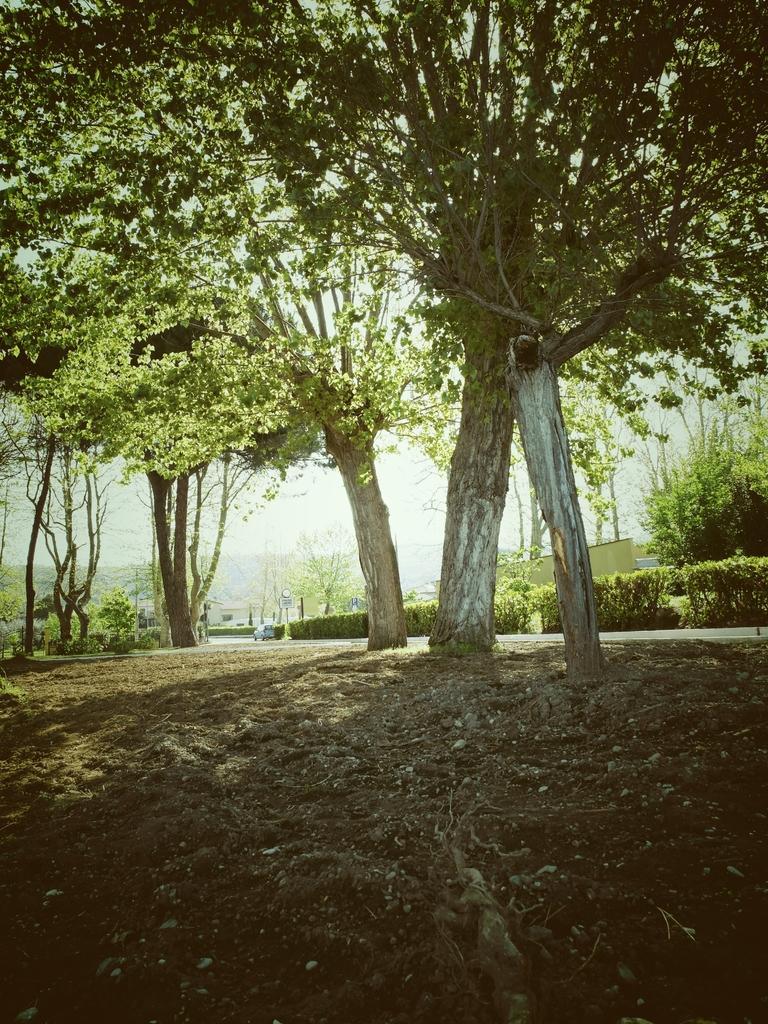Could you give a brief overview of what you see in this image? In this image, in the middle there are trees, at the bottom it is the soil. 